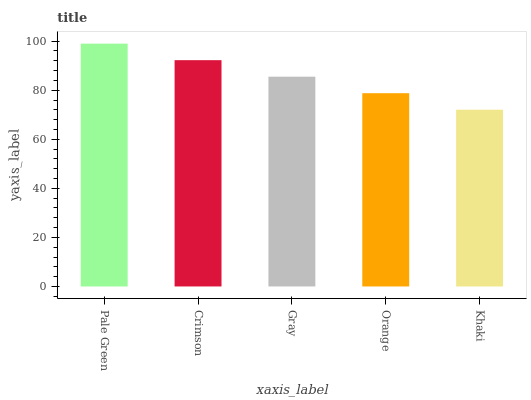Is Khaki the minimum?
Answer yes or no. Yes. Is Pale Green the maximum?
Answer yes or no. Yes. Is Crimson the minimum?
Answer yes or no. No. Is Crimson the maximum?
Answer yes or no. No. Is Pale Green greater than Crimson?
Answer yes or no. Yes. Is Crimson less than Pale Green?
Answer yes or no. Yes. Is Crimson greater than Pale Green?
Answer yes or no. No. Is Pale Green less than Crimson?
Answer yes or no. No. Is Gray the high median?
Answer yes or no. Yes. Is Gray the low median?
Answer yes or no. Yes. Is Khaki the high median?
Answer yes or no. No. Is Crimson the low median?
Answer yes or no. No. 